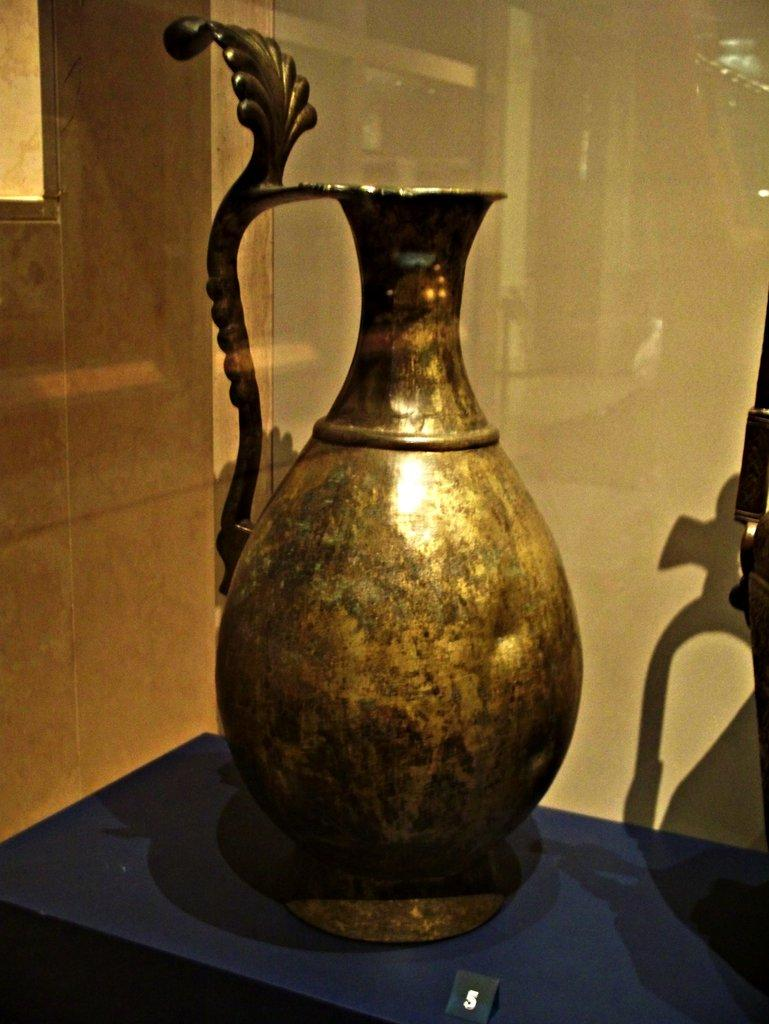What type of object is in the image? There is a metal vase in the image. Where is the metal vase located? The metal vase is present on a table. What type of liquid is present inside the metal vase in the image? There is no indication of any liquid present inside the metal vase in the image. How does the metal vase maintain its balance on the table in the image? The metal vase maintains its balance on the table through its stable base and the table's surface, but there is no specific information about how it maintains its balance in the image. 